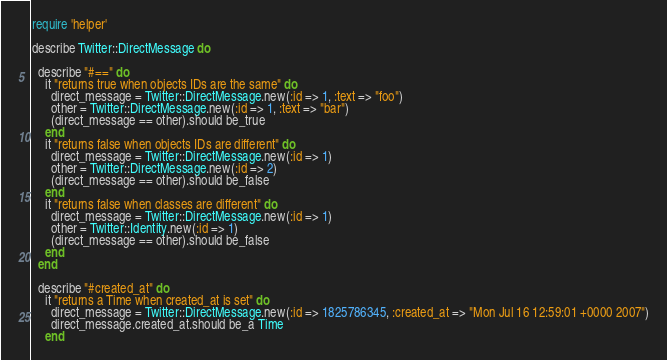Convert code to text. <code><loc_0><loc_0><loc_500><loc_500><_Ruby_>require 'helper'

describe Twitter::DirectMessage do

  describe "#==" do
    it "returns true when objects IDs are the same" do
      direct_message = Twitter::DirectMessage.new(:id => 1, :text => "foo")
      other = Twitter::DirectMessage.new(:id => 1, :text => "bar")
      (direct_message == other).should be_true
    end
    it "returns false when objects IDs are different" do
      direct_message = Twitter::DirectMessage.new(:id => 1)
      other = Twitter::DirectMessage.new(:id => 2)
      (direct_message == other).should be_false
    end
    it "returns false when classes are different" do
      direct_message = Twitter::DirectMessage.new(:id => 1)
      other = Twitter::Identity.new(:id => 1)
      (direct_message == other).should be_false
    end
  end

  describe "#created_at" do
    it "returns a Time when created_at is set" do
      direct_message = Twitter::DirectMessage.new(:id => 1825786345, :created_at => "Mon Jul 16 12:59:01 +0000 2007")
      direct_message.created_at.should be_a Time
    end</code> 